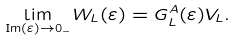<formula> <loc_0><loc_0><loc_500><loc_500>\lim _ { \text {Im} ( \varepsilon ) \rightarrow 0 _ { - } } W _ { L } ( \varepsilon ) = G _ { L } ^ { A } ( \varepsilon ) V _ { L } .</formula> 